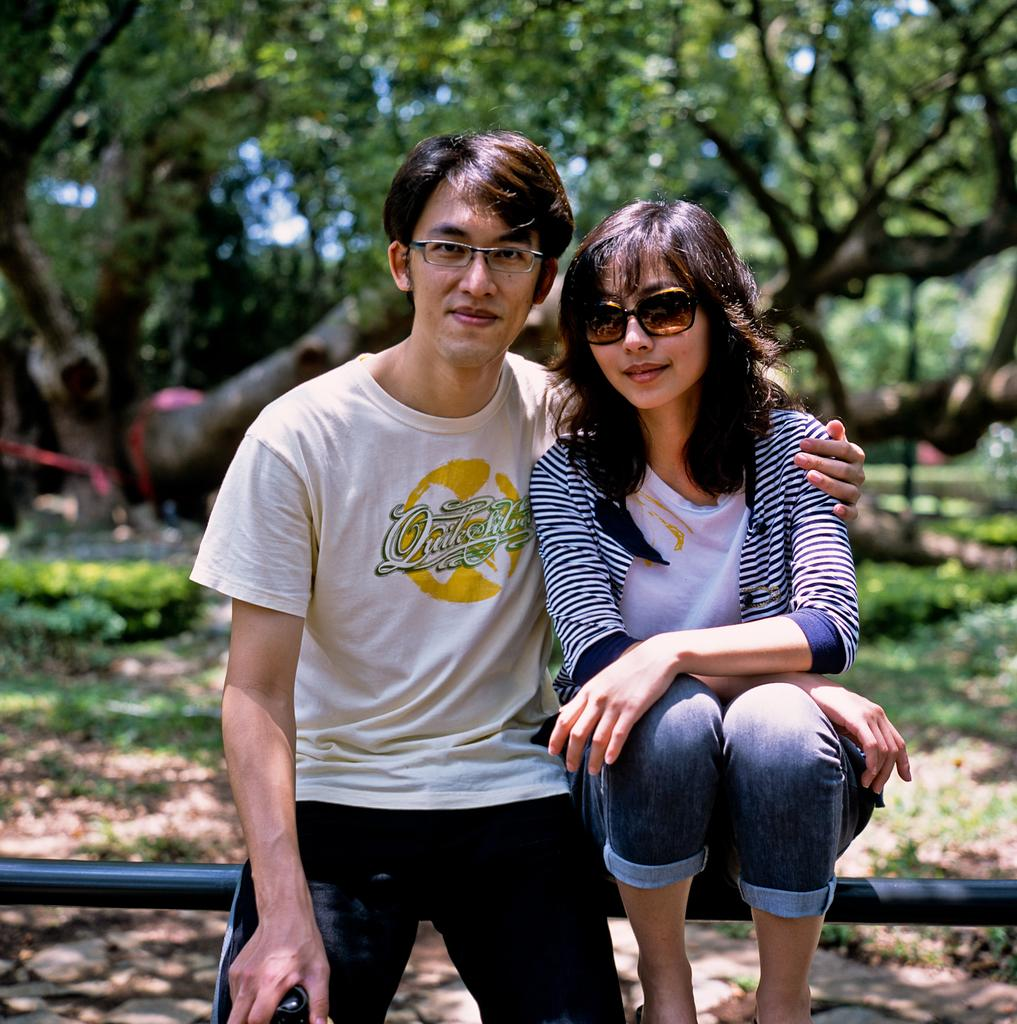Who are the subjects in the image? There is a boy and a girl in the image. Where are the boy and girl located in the image? The boy and girl are in the center of the image. What is behind the boy and girl? There is a boundary behind the boy and girl. What can be seen in the background of the image? There are trees in the background of the image. What type of dirt can be seen on the cat's paws in the image? There is no cat present in the image, so there is no dirt on its paws. 